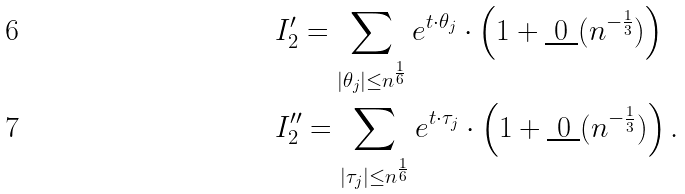<formula> <loc_0><loc_0><loc_500><loc_500>& I ^ { \prime } _ { 2 } = \sum _ { | \theta _ { j } | \leq n ^ { \frac { 1 } { 6 } } } e ^ { t \cdot \theta _ { j } } \cdot \left ( 1 + \underbar { 0 } ( n ^ { - \frac { 1 } { 3 } } ) \right ) \\ & I ^ { \prime \prime } _ { 2 } = \sum _ { | \tau _ { j } | \leq n ^ { \frac { 1 } { 6 } } } e ^ { t \cdot \tau _ { j } } \cdot \left ( 1 + \underbar { 0 } ( n ^ { - \frac { 1 } { 3 } } ) \right ) .</formula> 